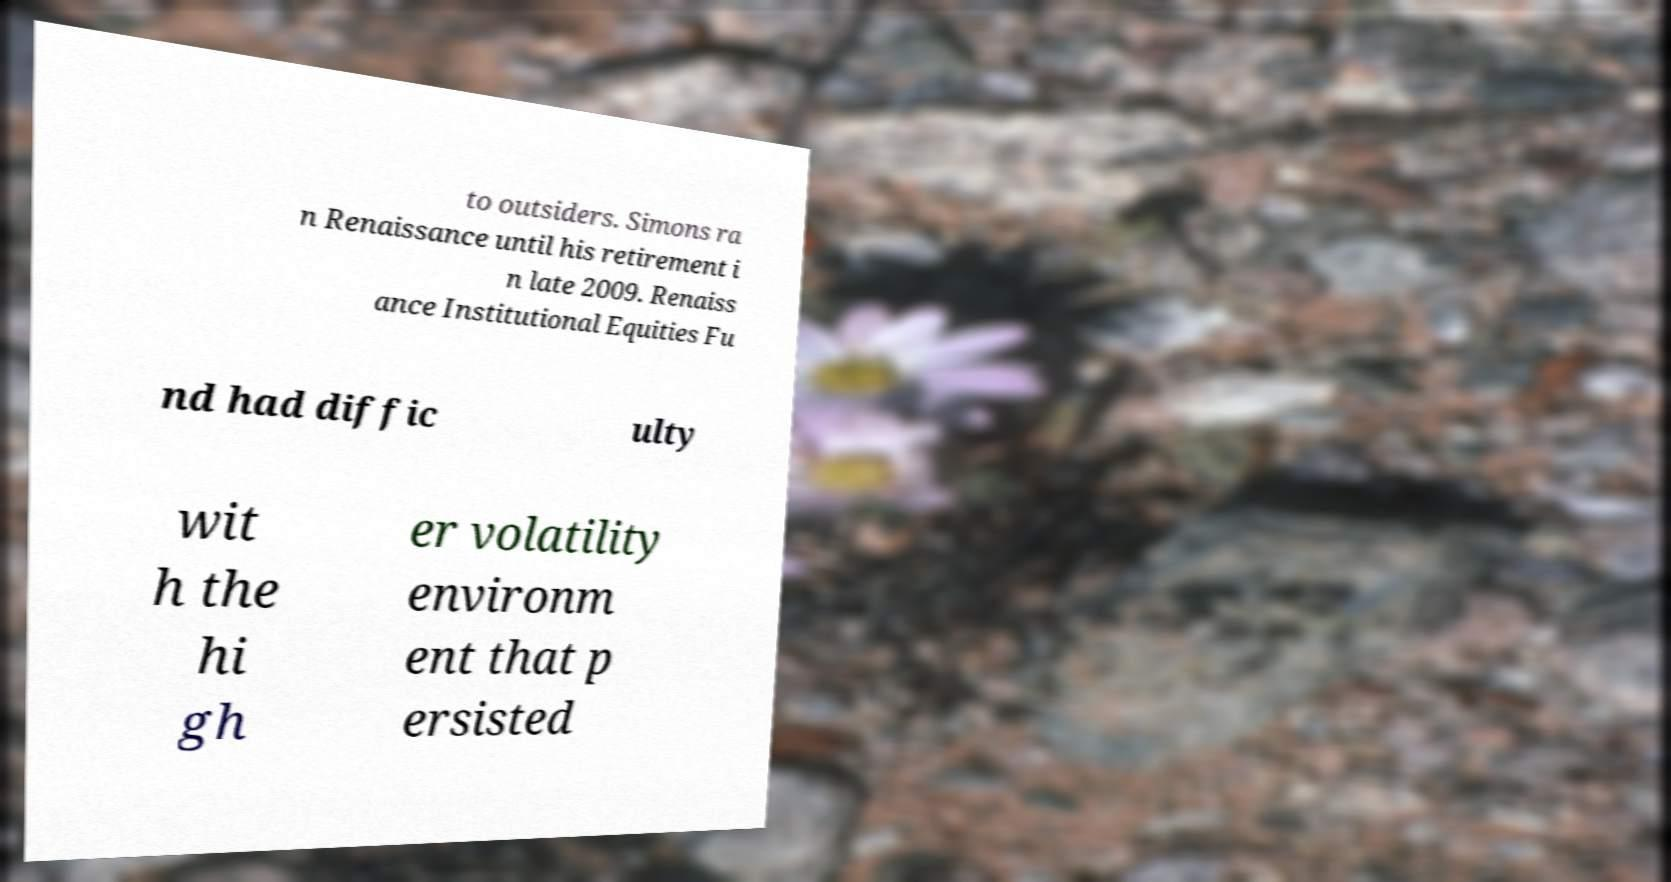There's text embedded in this image that I need extracted. Can you transcribe it verbatim? to outsiders. Simons ra n Renaissance until his retirement i n late 2009. Renaiss ance Institutional Equities Fu nd had diffic ulty wit h the hi gh er volatility environm ent that p ersisted 